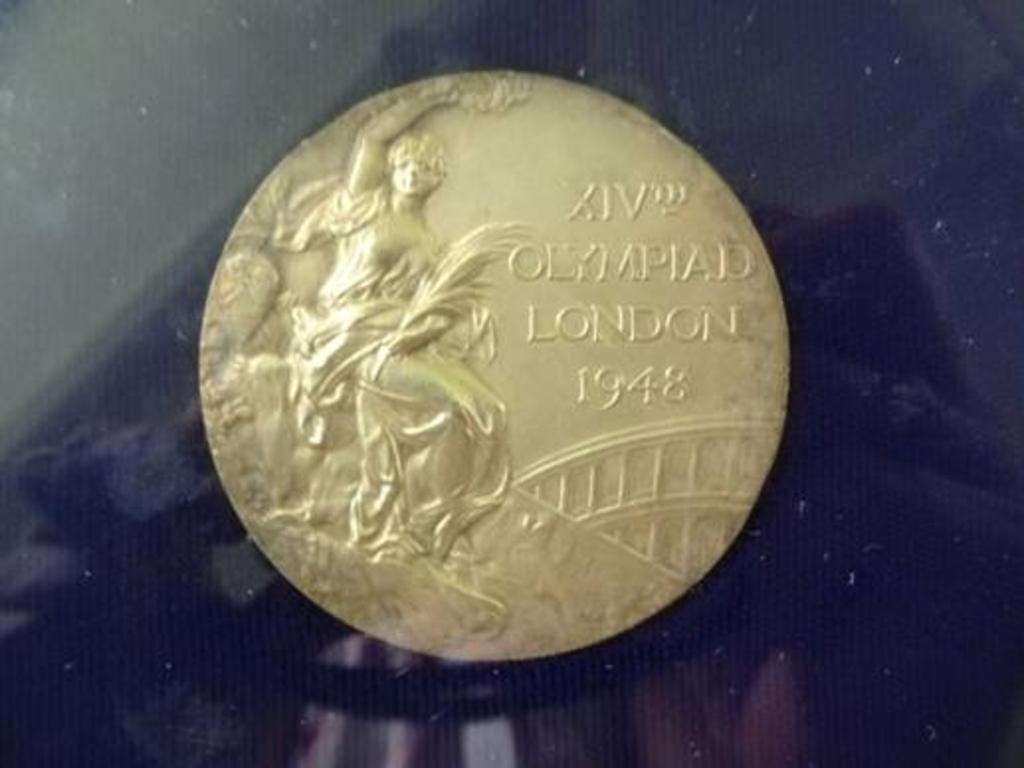<image>
Describe the image concisely. a gold coin that says olympiad london 1948 on it 